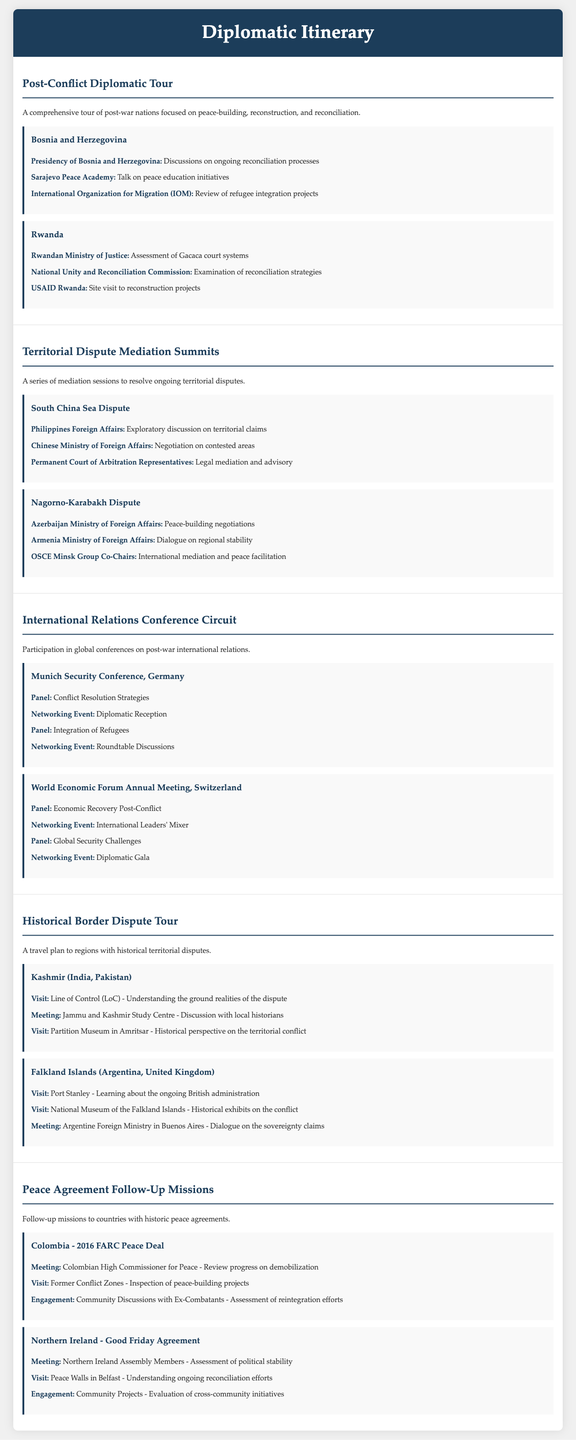What is the first meeting in the Post-Conflict Diplomatic Tour? The first meeting listed is with the Presidency of Bosnia and Herzegovina discussing ongoing reconciliation processes.
Answer: Presidency of Bosnia and Herzegovina Which commission is involved in Rwanda's reconciliation strategies? The National Unity and Reconciliation Commission is mentioned in connection with examination of reconciliation strategies.
Answer: National Unity and Reconciliation Commission What topic is discussed at the Munich Security Conference regarding refugee integration? A panel on the integration of refugees is scheduled at the Munich Security Conference.
Answer: Integration of Refugees Which organization represents legal mediation in the South China Sea Dispute? Permanent Court of Arbitration Representatives are mentioned as representing legal mediation and advisory.
Answer: Permanent Court of Arbitration Representatives How many meetings are listed in the Peace Agreement Follow-Up Missions section? There are a total of four meetings listed across two missions in the Peace Agreement Follow-Up Missions section.
Answer: Four meetings 